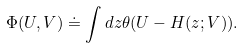Convert formula to latex. <formula><loc_0><loc_0><loc_500><loc_500>\Phi ( U , V ) \doteq \int d z \theta ( U - H ( z ; V ) ) .</formula> 